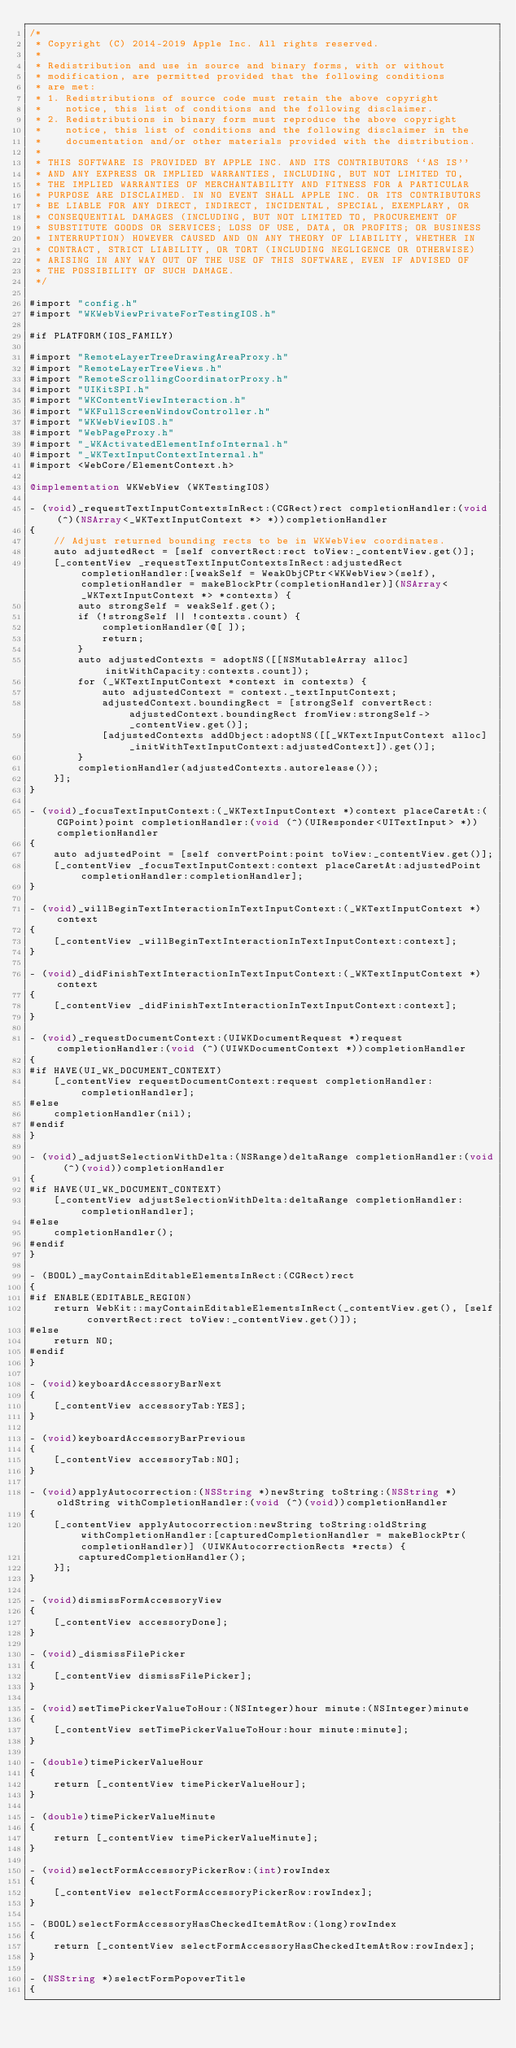Convert code to text. <code><loc_0><loc_0><loc_500><loc_500><_ObjectiveC_>/*
 * Copyright (C) 2014-2019 Apple Inc. All rights reserved.
 *
 * Redistribution and use in source and binary forms, with or without
 * modification, are permitted provided that the following conditions
 * are met:
 * 1. Redistributions of source code must retain the above copyright
 *    notice, this list of conditions and the following disclaimer.
 * 2. Redistributions in binary form must reproduce the above copyright
 *    notice, this list of conditions and the following disclaimer in the
 *    documentation and/or other materials provided with the distribution.
 *
 * THIS SOFTWARE IS PROVIDED BY APPLE INC. AND ITS CONTRIBUTORS ``AS IS''
 * AND ANY EXPRESS OR IMPLIED WARRANTIES, INCLUDING, BUT NOT LIMITED TO,
 * THE IMPLIED WARRANTIES OF MERCHANTABILITY AND FITNESS FOR A PARTICULAR
 * PURPOSE ARE DISCLAIMED. IN NO EVENT SHALL APPLE INC. OR ITS CONTRIBUTORS
 * BE LIABLE FOR ANY DIRECT, INDIRECT, INCIDENTAL, SPECIAL, EXEMPLARY, OR
 * CONSEQUENTIAL DAMAGES (INCLUDING, BUT NOT LIMITED TO, PROCUREMENT OF
 * SUBSTITUTE GOODS OR SERVICES; LOSS OF USE, DATA, OR PROFITS; OR BUSINESS
 * INTERRUPTION) HOWEVER CAUSED AND ON ANY THEORY OF LIABILITY, WHETHER IN
 * CONTRACT, STRICT LIABILITY, OR TORT (INCLUDING NEGLIGENCE OR OTHERWISE)
 * ARISING IN ANY WAY OUT OF THE USE OF THIS SOFTWARE, EVEN IF ADVISED OF
 * THE POSSIBILITY OF SUCH DAMAGE.
 */

#import "config.h"
#import "WKWebViewPrivateForTestingIOS.h"

#if PLATFORM(IOS_FAMILY)

#import "RemoteLayerTreeDrawingAreaProxy.h"
#import "RemoteLayerTreeViews.h"
#import "RemoteScrollingCoordinatorProxy.h"
#import "UIKitSPI.h"
#import "WKContentViewInteraction.h"
#import "WKFullScreenWindowController.h"
#import "WKWebViewIOS.h"
#import "WebPageProxy.h"
#import "_WKActivatedElementInfoInternal.h"
#import "_WKTextInputContextInternal.h"
#import <WebCore/ElementContext.h>

@implementation WKWebView (WKTestingIOS)

- (void)_requestTextInputContextsInRect:(CGRect)rect completionHandler:(void (^)(NSArray<_WKTextInputContext *> *))completionHandler
{
    // Adjust returned bounding rects to be in WKWebView coordinates.
    auto adjustedRect = [self convertRect:rect toView:_contentView.get()];
    [_contentView _requestTextInputContextsInRect:adjustedRect completionHandler:[weakSelf = WeakObjCPtr<WKWebView>(self), completionHandler = makeBlockPtr(completionHandler)](NSArray<_WKTextInputContext *> *contexts) {
        auto strongSelf = weakSelf.get();
        if (!strongSelf || !contexts.count) {
            completionHandler(@[ ]);
            return;
        }
        auto adjustedContexts = adoptNS([[NSMutableArray alloc] initWithCapacity:contexts.count]);
        for (_WKTextInputContext *context in contexts) {
            auto adjustedContext = context._textInputContext;
            adjustedContext.boundingRect = [strongSelf convertRect:adjustedContext.boundingRect fromView:strongSelf->_contentView.get()];
            [adjustedContexts addObject:adoptNS([[_WKTextInputContext alloc] _initWithTextInputContext:adjustedContext]).get()];
        }
        completionHandler(adjustedContexts.autorelease());
    }];
}

- (void)_focusTextInputContext:(_WKTextInputContext *)context placeCaretAt:(CGPoint)point completionHandler:(void (^)(UIResponder<UITextInput> *))completionHandler
{
    auto adjustedPoint = [self convertPoint:point toView:_contentView.get()];
    [_contentView _focusTextInputContext:context placeCaretAt:adjustedPoint completionHandler:completionHandler];
}

- (void)_willBeginTextInteractionInTextInputContext:(_WKTextInputContext *)context
{
    [_contentView _willBeginTextInteractionInTextInputContext:context];
}

- (void)_didFinishTextInteractionInTextInputContext:(_WKTextInputContext *)context
{
    [_contentView _didFinishTextInteractionInTextInputContext:context];
}

- (void)_requestDocumentContext:(UIWKDocumentRequest *)request completionHandler:(void (^)(UIWKDocumentContext *))completionHandler
{
#if HAVE(UI_WK_DOCUMENT_CONTEXT)
    [_contentView requestDocumentContext:request completionHandler:completionHandler];
#else
    completionHandler(nil);
#endif
}

- (void)_adjustSelectionWithDelta:(NSRange)deltaRange completionHandler:(void (^)(void))completionHandler
{
#if HAVE(UI_WK_DOCUMENT_CONTEXT)
    [_contentView adjustSelectionWithDelta:deltaRange completionHandler:completionHandler];
#else
    completionHandler();
#endif
}

- (BOOL)_mayContainEditableElementsInRect:(CGRect)rect
{
#if ENABLE(EDITABLE_REGION)
    return WebKit::mayContainEditableElementsInRect(_contentView.get(), [self convertRect:rect toView:_contentView.get()]);
#else
    return NO;
#endif
}

- (void)keyboardAccessoryBarNext
{
    [_contentView accessoryTab:YES];
}

- (void)keyboardAccessoryBarPrevious
{
    [_contentView accessoryTab:NO];
}

- (void)applyAutocorrection:(NSString *)newString toString:(NSString *)oldString withCompletionHandler:(void (^)(void))completionHandler
{
    [_contentView applyAutocorrection:newString toString:oldString withCompletionHandler:[capturedCompletionHandler = makeBlockPtr(completionHandler)] (UIWKAutocorrectionRects *rects) {
        capturedCompletionHandler();
    }];
}

- (void)dismissFormAccessoryView
{
    [_contentView accessoryDone];
}

- (void)_dismissFilePicker
{
    [_contentView dismissFilePicker];
}

- (void)setTimePickerValueToHour:(NSInteger)hour minute:(NSInteger)minute
{
    [_contentView setTimePickerValueToHour:hour minute:minute];
}

- (double)timePickerValueHour
{
    return [_contentView timePickerValueHour];
}

- (double)timePickerValueMinute
{
    return [_contentView timePickerValueMinute];
}

- (void)selectFormAccessoryPickerRow:(int)rowIndex
{
    [_contentView selectFormAccessoryPickerRow:rowIndex];
}

- (BOOL)selectFormAccessoryHasCheckedItemAtRow:(long)rowIndex
{
    return [_contentView selectFormAccessoryHasCheckedItemAtRow:rowIndex];
}

- (NSString *)selectFormPopoverTitle
{</code> 